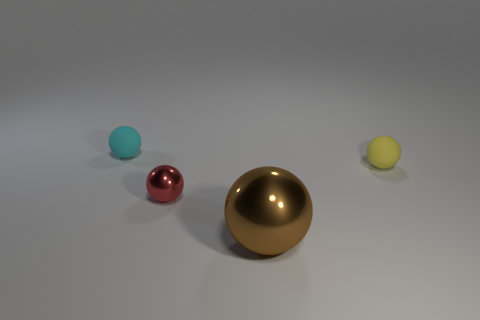Considering the composition, what might be the purpose of this image? The composition of this image suggests it could be used for a variety of purposes, such as a study in lighting, texture, and reflections for 3D rendering, an advertisement for design-related products, or as part of a visual arts project. What does the varying size and color of the balls contribute to the composition? The variance in size creates a sense of depth and perspective, while the contrasting colors can draw the viewer's eye across the image, suggesting harmony and balance within the visual composition. 